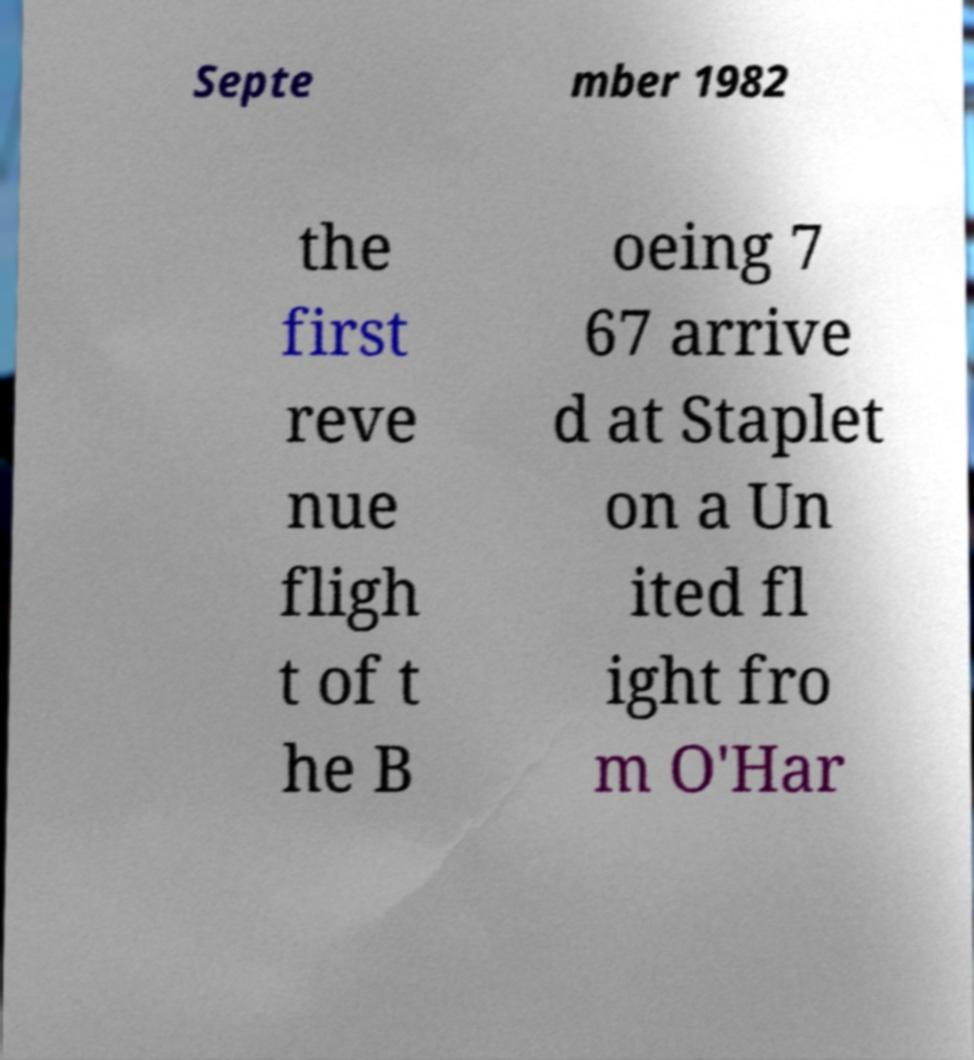Could you extract and type out the text from this image? Septe mber 1982 the first reve nue fligh t of t he B oeing 7 67 arrive d at Staplet on a Un ited fl ight fro m O'Har 